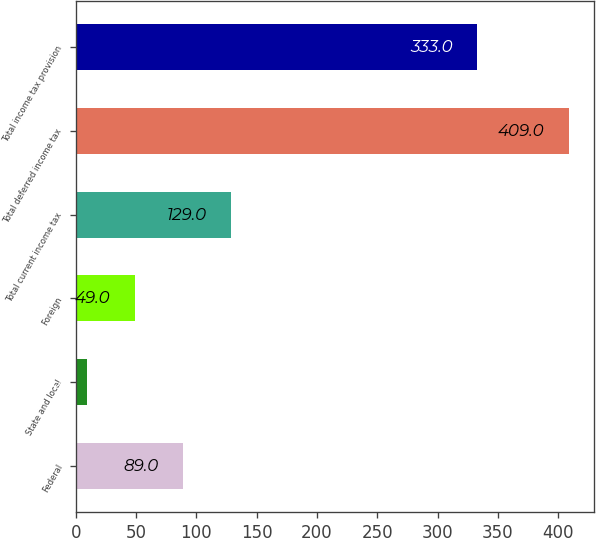Convert chart. <chart><loc_0><loc_0><loc_500><loc_500><bar_chart><fcel>Federal<fcel>State and local<fcel>Foreign<fcel>Total current income tax<fcel>Total deferred income tax<fcel>Total income tax provision<nl><fcel>89<fcel>9<fcel>49<fcel>129<fcel>409<fcel>333<nl></chart> 